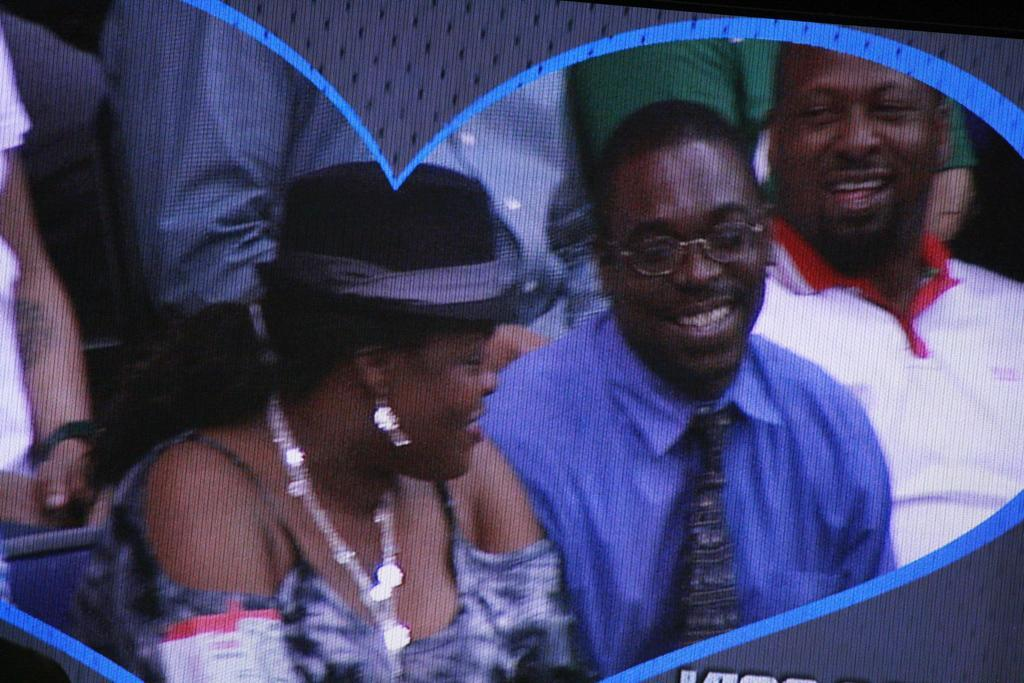What is happening in the image? There are people sitting in the image. Can you describe the people in the image? There is a woman among the people sitting. What type of throne is the woman sitting on in the image? There is no throne present in the image; the people are sitting on chairs or a bench. How many flies can be seen buzzing around the woman in the image? There are no flies present in the image. 